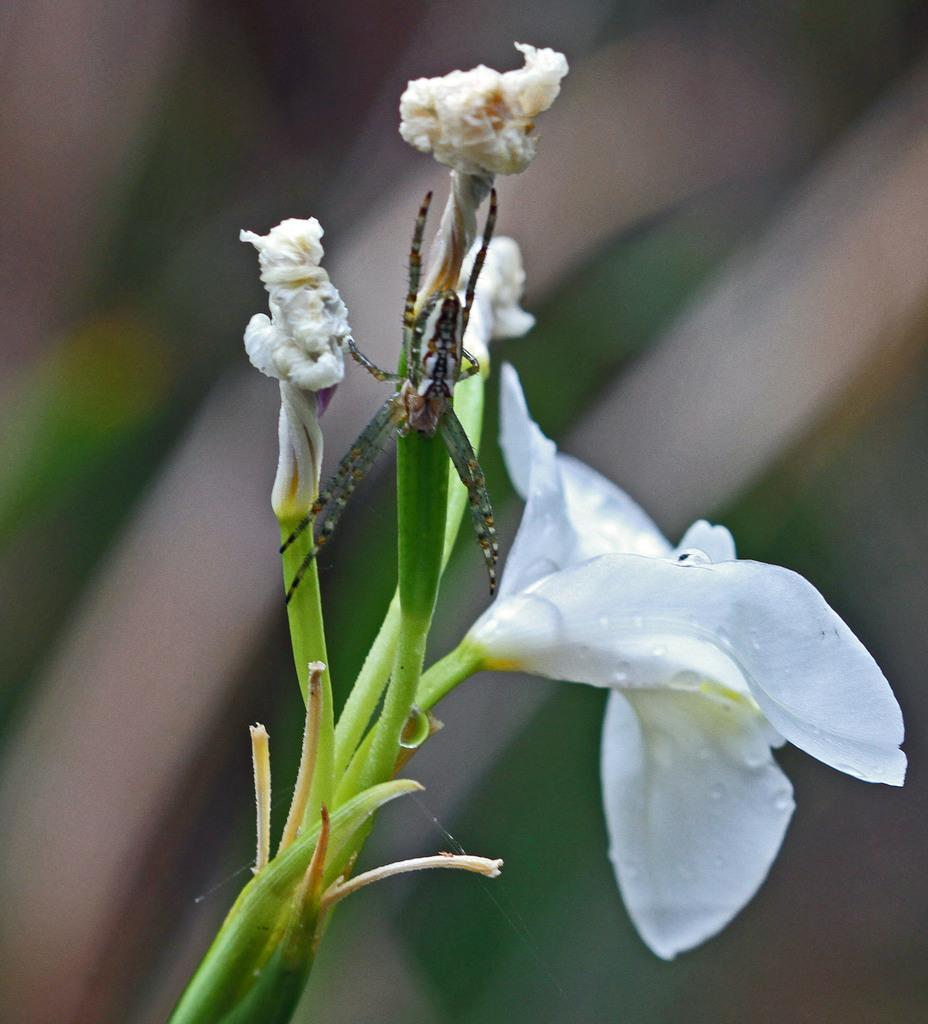What type of creature is present in the image? There is an insect in the image. Where is the insect located? The insect is on a flower plant. What type of art is displayed on the wall behind the insect? There is no art displayed on the wall behind the insect in the image. What type of home is the insect located in? The image does not provide information about the type of home; it only shows the insect on a flower plant. 